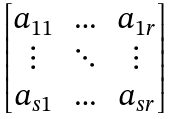Convert formula to latex. <formula><loc_0><loc_0><loc_500><loc_500>\begin{bmatrix} a _ { 1 1 } & \hdots & a _ { 1 r } \\ \vdots & \ddots & \vdots \\ a _ { s 1 } & \hdots & a _ { s r } \end{bmatrix}</formula> 